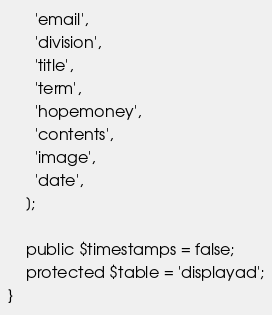Convert code to text. <code><loc_0><loc_0><loc_500><loc_500><_PHP_>      'email',
      'division',
      'title',
      'term',
      'hopemoney',
      'contents',
      'image',
      'date',
    ];

    public $timestamps = false;
    protected $table = 'displayad';
}
</code> 